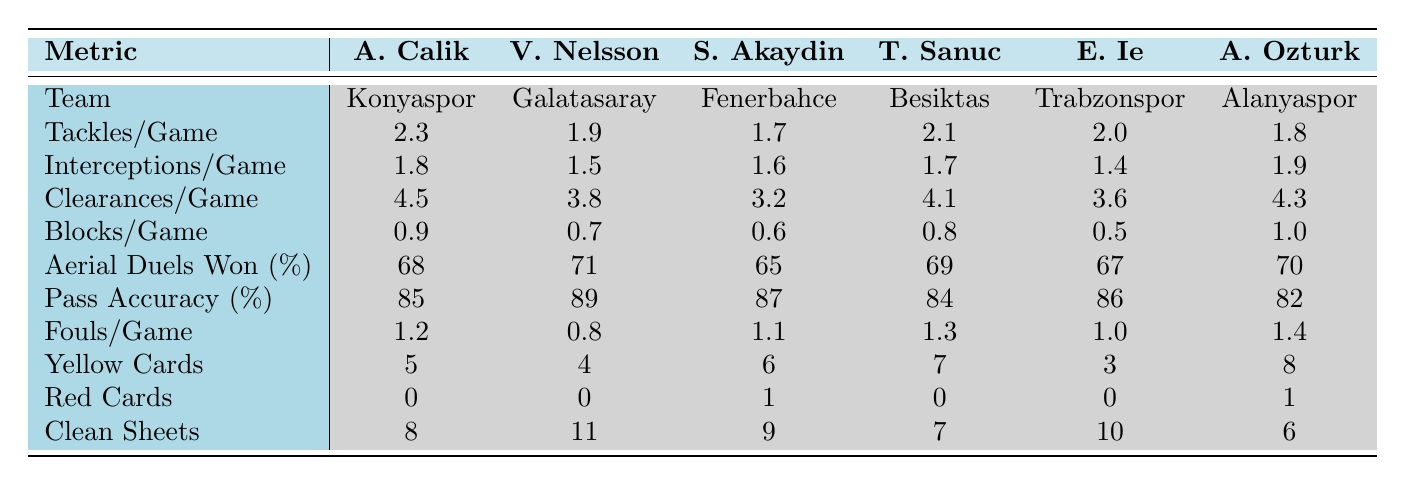What is Ahmet Calik's average tackles per game? The table shows that Ahmet Calik has 2.3 tackles per game.
Answer: 2.3 Which player has the highest number of clean sheets? According to the table, Victor Nelsson has the highest with 11 clean sheets.
Answer: Victor Nelsson How many more clean sheets does Ahmet Calik have compared to Tayyib Sanuc? Ahmet Calik has 8 clean sheets and Tayyib Sanuc has 7. The difference is 8 - 7 = 1.
Answer: 1 Is Ahmet Calik's pass accuracy higher than Samet Akaydin's? Ahmet Calik's pass accuracy is 85%, while Samet Akaydin's is 87%. Since 85% < 87%, the statement is false.
Answer: No How many total fouls per game does all players combined commit on average? The total fouls per game for all players are 1.2 + 0.8 + 1.1 + 1.3 + 1.0 + 1.4 = 6.8. There are 6 players, so the average fouls per game is 6.8 / 6 = 1.13.
Answer: 1.13 Which player has the lowest aerial duels won percentage? The table indicates that Samet Akaydin has the lowest aerial duels won percentage at 65%.
Answer: Samet Akaydin Are there any players with more blocks per game than Ahmet Calik? Ahmet Calik has 0.9 blocks per game. The only player with more blocks is Alpaslan Ozturk, who has 1.0, so yes, there is one.
Answer: Yes What is the total number of yellow cards received by all players? The total number of yellow cards is 5 + 4 + 6 + 7 + 3 + 8 = 33.
Answer: 33 How does Ahmet Calik's interceptions per game compare to Edgar Ie's? Ahmet Calik has 1.8 interceptions per game, while Edgar Ie has 1.4. Since 1.8 > 1.4, Calik has more interceptions.
Answer: More Which player has the highest tackle per game ratio? Ahmet Calik has the highest with 2.3 tackles per game, higher than any other player in the table.
Answer: Ahmet Calik 